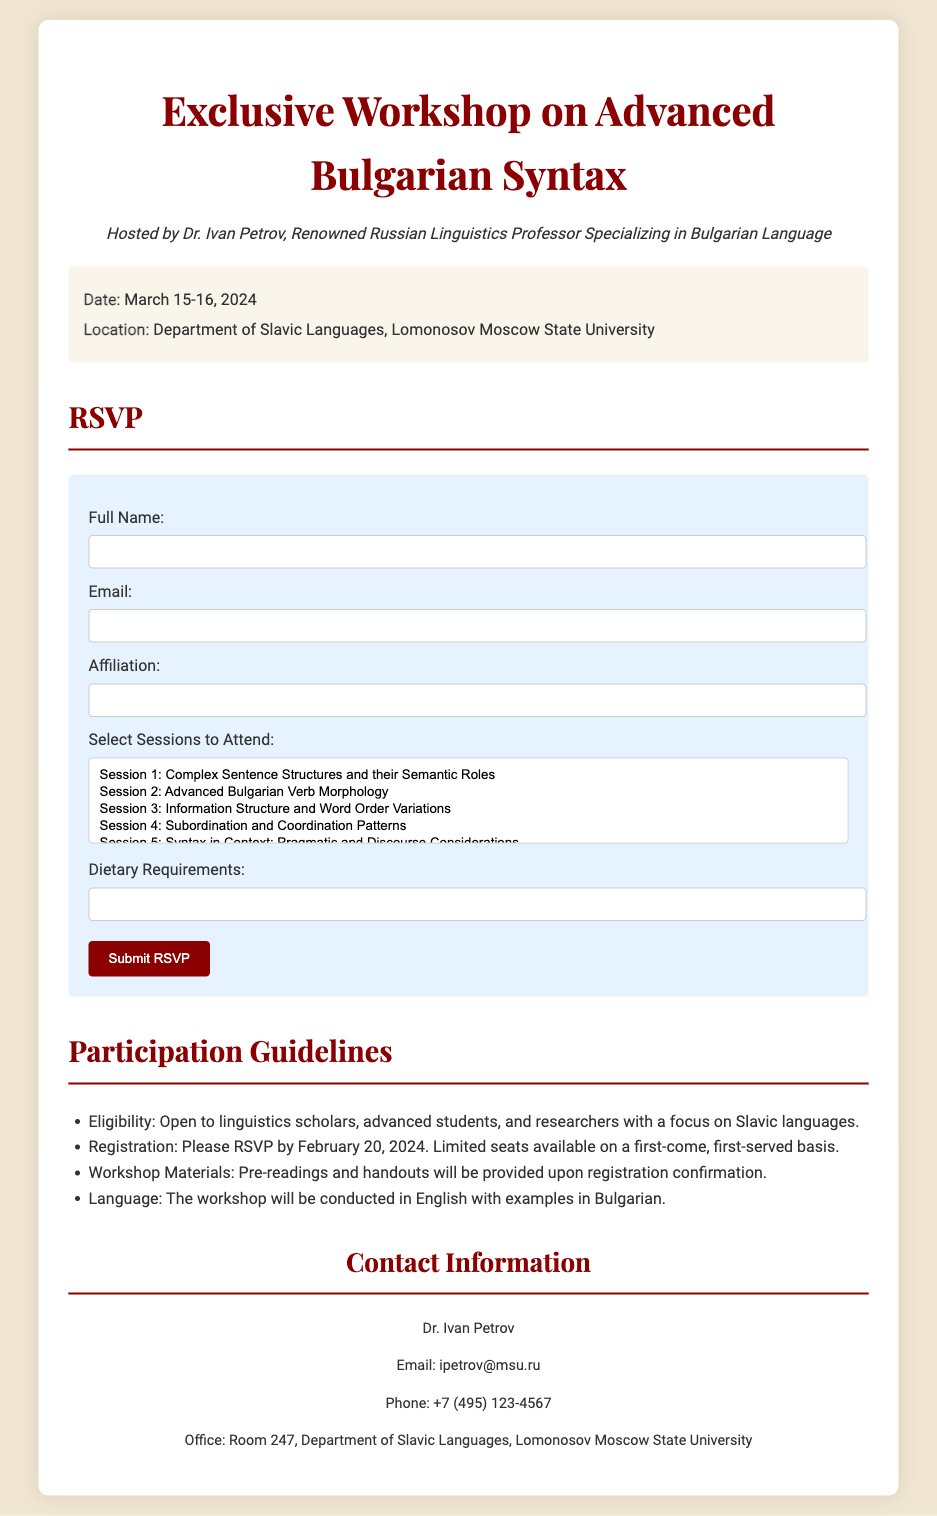what are the dates of the workshop? The dates of the workshop are explicitly stated in the document as March 15-16, 2024.
Answer: March 15-16, 2024 who is hosting the workshop? The document names Dr. Ivan Petrov as the host of the workshop.
Answer: Dr. Ivan Petrov where is the workshop located? The document specifies the location as the Department of Slavic Languages, Lomonosov Moscow State University.
Answer: Department of Slavic Languages, Lomonosov Moscow State University by what date should participants RSVP? The deadline for RSVP is indicated in the document as February 20, 2024.
Answer: February 20, 2024 what is one of the topics covered in the workshop? The document lists several session topics; one specific topic is "Advanced Bulgarian Verb Morphology."
Answer: Advanced Bulgarian Verb Morphology what language will the workshop be conducted in? The document states that the workshop will be conducted in English with examples in Bulgarian.
Answer: English how many sessions can participants choose from? The document provides a selection of six sessions available for participants to choose from.
Answer: Six what is provided upon registration confirmation? According to the document, pre-readings and handouts will be provided upon registration confirmation.
Answer: Pre-readings and handouts what type of participants is the workshop open to? The document indicates that the workshop is open to linguistics scholars, advanced students, and researchers.
Answer: Linguistics scholars, advanced students, and researchers 